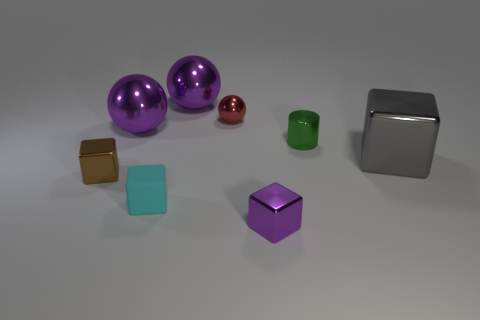Add 1 brown cubes. How many objects exist? 9 Subtract all balls. How many objects are left? 5 Subtract all brown blocks. How many blocks are left? 3 Subtract all shiny cubes. How many cubes are left? 1 Subtract 1 red balls. How many objects are left? 7 Subtract 2 spheres. How many spheres are left? 1 Subtract all gray spheres. Subtract all blue blocks. How many spheres are left? 3 Subtract all yellow blocks. How many purple spheres are left? 2 Subtract all small green balls. Subtract all gray things. How many objects are left? 7 Add 5 blocks. How many blocks are left? 9 